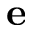<formula> <loc_0><loc_0><loc_500><loc_500>e</formula> 